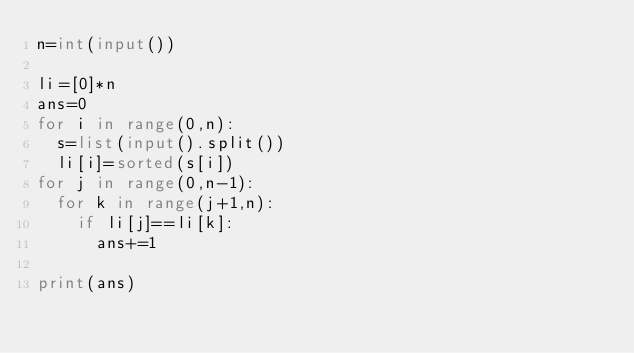<code> <loc_0><loc_0><loc_500><loc_500><_Python_>n=int(input())

li=[0]*n
ans=0
for i in range(0,n):
  s=list(input().split())
  li[i]=sorted(s[i])
for j in range(0,n-1):
  for k in range(j+1,n):
    if li[j]==li[k]:
      ans+=1
      
print(ans)      
</code> 